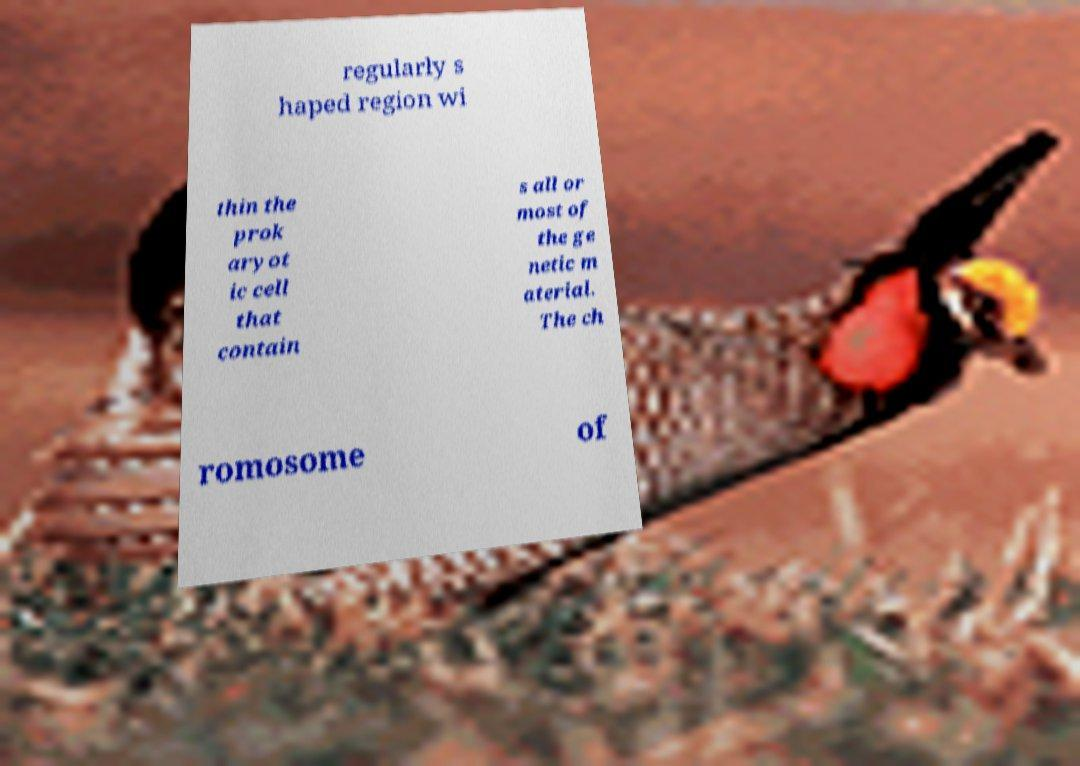Can you read and provide the text displayed in the image?This photo seems to have some interesting text. Can you extract and type it out for me? regularly s haped region wi thin the prok aryot ic cell that contain s all or most of the ge netic m aterial. The ch romosome of 